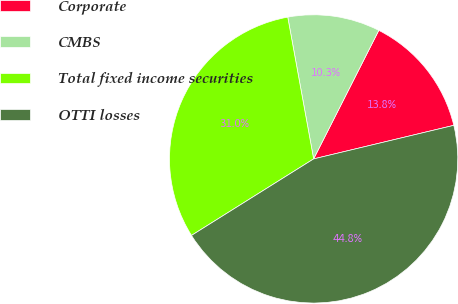Convert chart. <chart><loc_0><loc_0><loc_500><loc_500><pie_chart><fcel>Corporate<fcel>CMBS<fcel>Total fixed income securities<fcel>OTTI losses<nl><fcel>13.79%<fcel>10.34%<fcel>31.03%<fcel>44.83%<nl></chart> 